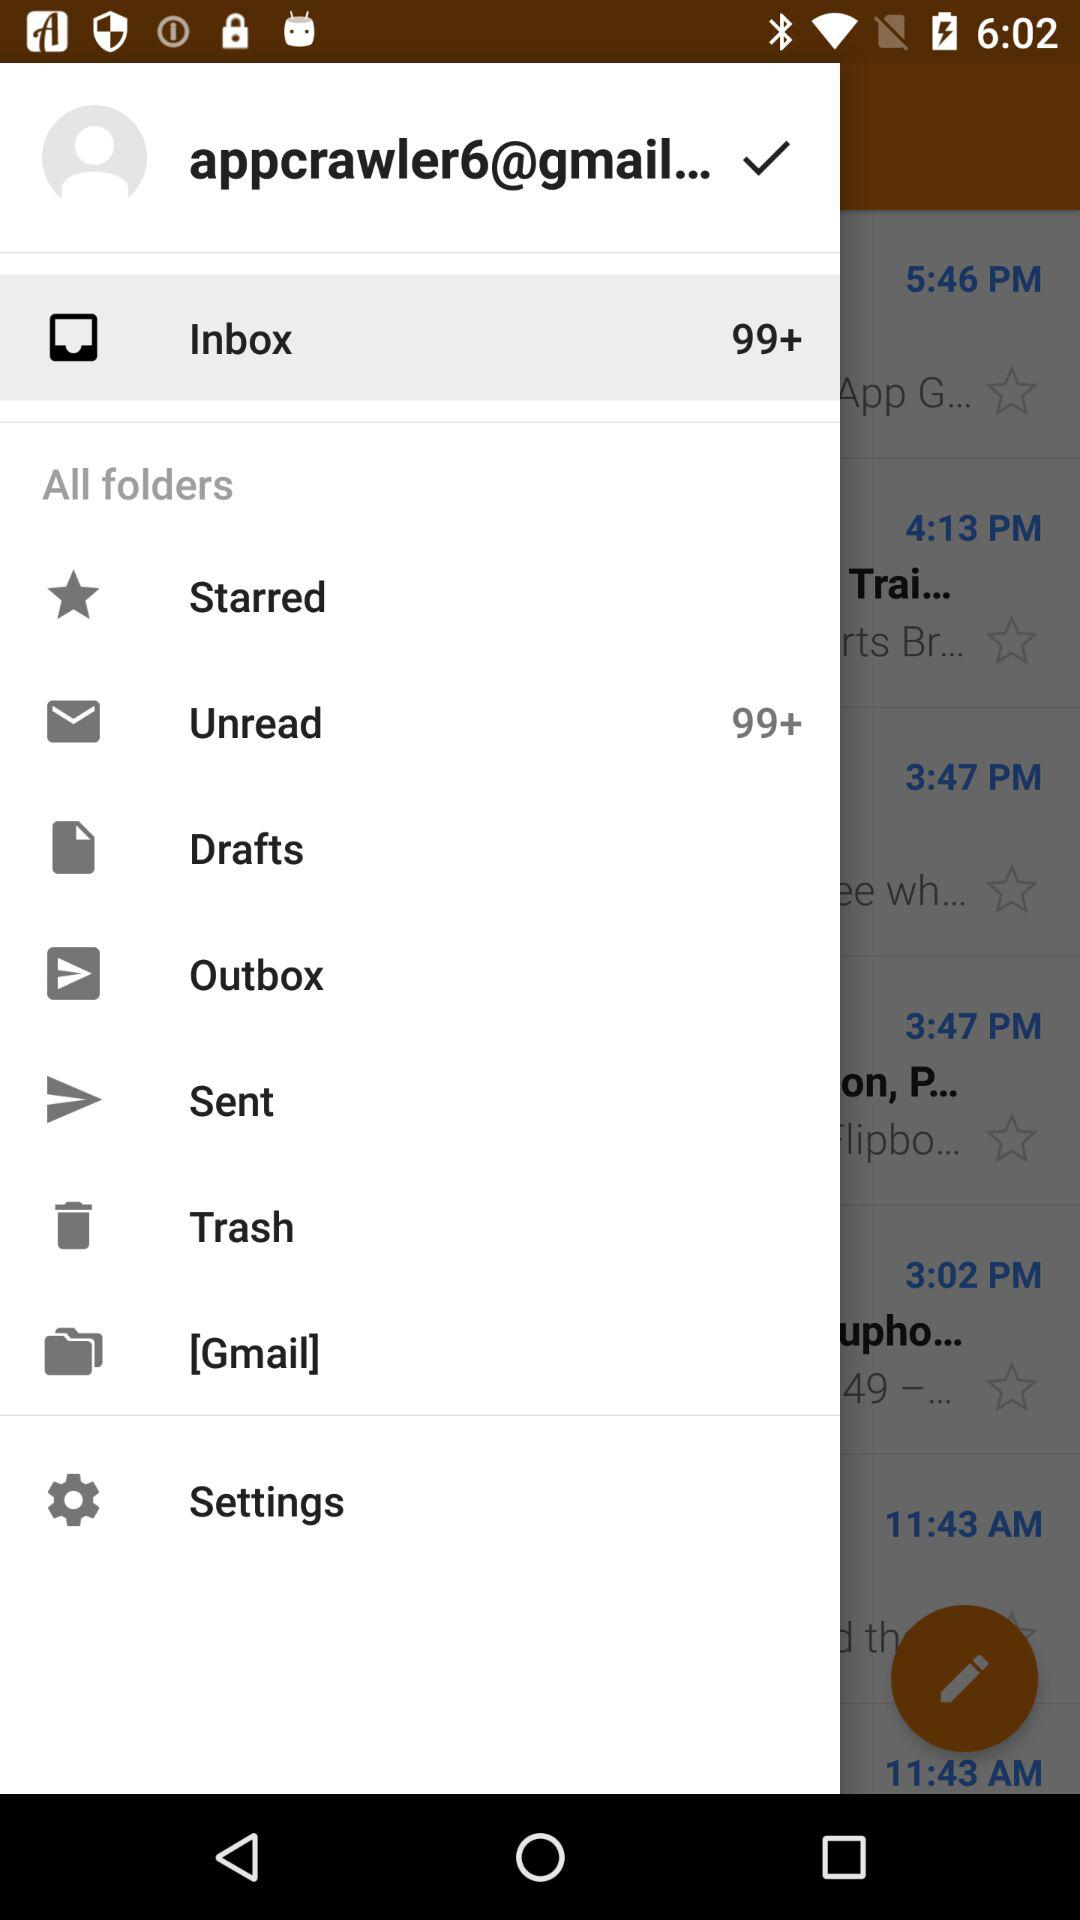What is the Gmail address? The Gmail address is "appcrawler6@gmail...". 